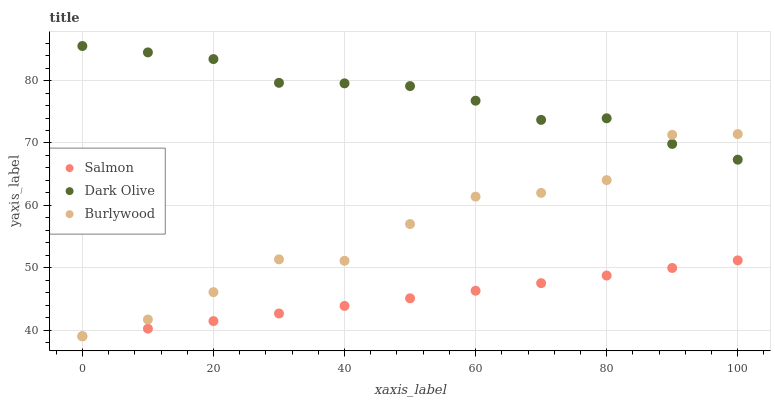Does Salmon have the minimum area under the curve?
Answer yes or no. Yes. Does Dark Olive have the maximum area under the curve?
Answer yes or no. Yes. Does Dark Olive have the minimum area under the curve?
Answer yes or no. No. Does Salmon have the maximum area under the curve?
Answer yes or no. No. Is Salmon the smoothest?
Answer yes or no. Yes. Is Burlywood the roughest?
Answer yes or no. Yes. Is Dark Olive the smoothest?
Answer yes or no. No. Is Dark Olive the roughest?
Answer yes or no. No. Does Burlywood have the lowest value?
Answer yes or no. Yes. Does Dark Olive have the lowest value?
Answer yes or no. No. Does Dark Olive have the highest value?
Answer yes or no. Yes. Does Salmon have the highest value?
Answer yes or no. No. Is Salmon less than Dark Olive?
Answer yes or no. Yes. Is Dark Olive greater than Salmon?
Answer yes or no. Yes. Does Dark Olive intersect Burlywood?
Answer yes or no. Yes. Is Dark Olive less than Burlywood?
Answer yes or no. No. Is Dark Olive greater than Burlywood?
Answer yes or no. No. Does Salmon intersect Dark Olive?
Answer yes or no. No. 